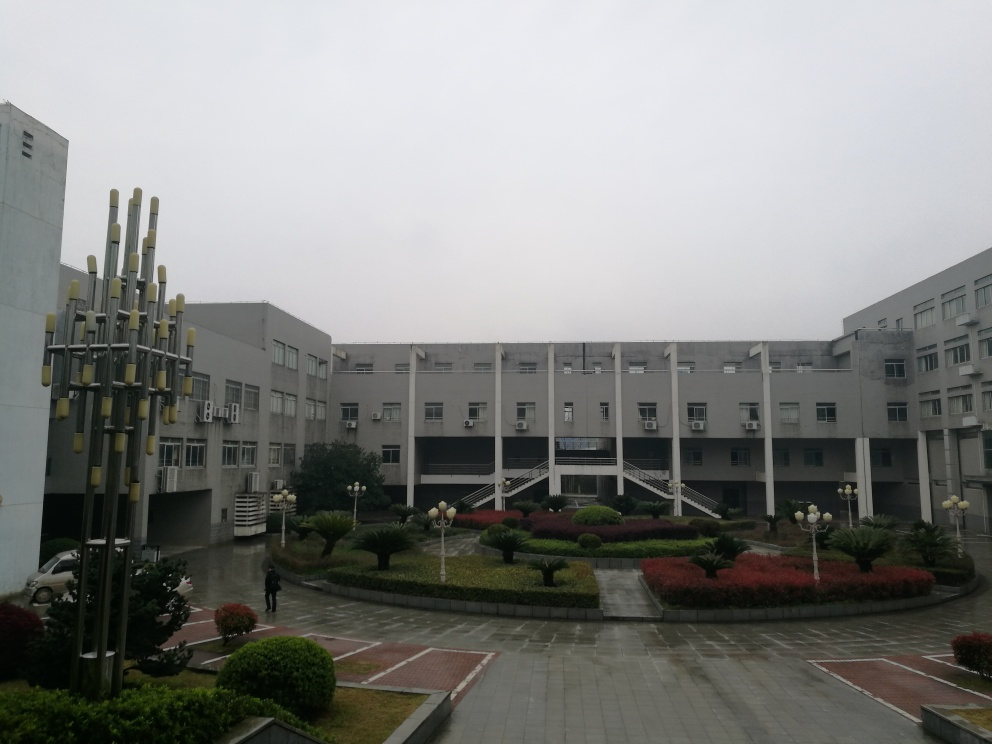What might be the purpose of the structure with multiple vertical elements in front of the building? Given its prominent location and organized structure, it's likely a piece of public art or an installation meant to enhance the visual appeal of the area and possibly serve as a landmark. The design appears abstract, encouraging onlookers to interpret its meaning individually. 